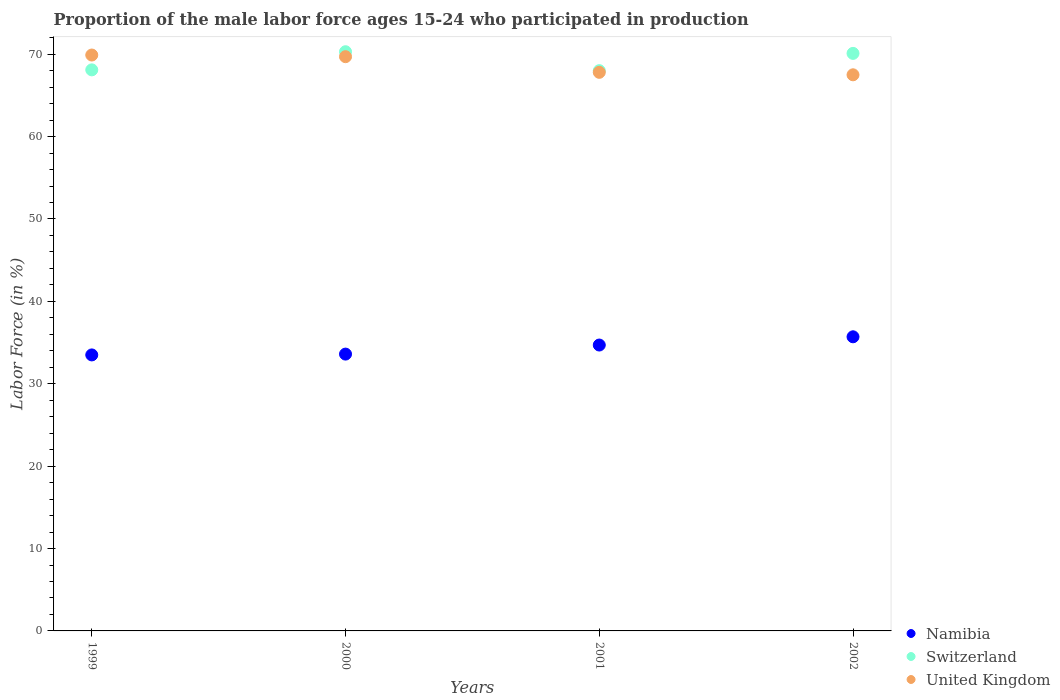How many different coloured dotlines are there?
Provide a short and direct response. 3. Is the number of dotlines equal to the number of legend labels?
Your answer should be compact. Yes. What is the proportion of the male labor force who participated in production in United Kingdom in 2000?
Offer a terse response. 69.7. Across all years, what is the maximum proportion of the male labor force who participated in production in United Kingdom?
Keep it short and to the point. 69.9. Across all years, what is the minimum proportion of the male labor force who participated in production in United Kingdom?
Offer a very short reply. 67.5. In which year was the proportion of the male labor force who participated in production in United Kingdom minimum?
Your answer should be compact. 2002. What is the total proportion of the male labor force who participated in production in Namibia in the graph?
Offer a very short reply. 137.5. What is the difference between the proportion of the male labor force who participated in production in Switzerland in 1999 and that in 2000?
Provide a short and direct response. -2.2. What is the difference between the proportion of the male labor force who participated in production in Switzerland in 2002 and the proportion of the male labor force who participated in production in Namibia in 2000?
Provide a succinct answer. 36.5. What is the average proportion of the male labor force who participated in production in Switzerland per year?
Offer a terse response. 69.12. In the year 2001, what is the difference between the proportion of the male labor force who participated in production in United Kingdom and proportion of the male labor force who participated in production in Namibia?
Your answer should be compact. 33.1. What is the ratio of the proportion of the male labor force who participated in production in United Kingdom in 2000 to that in 2001?
Provide a short and direct response. 1.03. Is the proportion of the male labor force who participated in production in Namibia in 1999 less than that in 2001?
Keep it short and to the point. Yes. Is the difference between the proportion of the male labor force who participated in production in United Kingdom in 1999 and 2000 greater than the difference between the proportion of the male labor force who participated in production in Namibia in 1999 and 2000?
Offer a very short reply. Yes. What is the difference between the highest and the second highest proportion of the male labor force who participated in production in Switzerland?
Offer a terse response. 0.2. What is the difference between the highest and the lowest proportion of the male labor force who participated in production in United Kingdom?
Give a very brief answer. 2.4. In how many years, is the proportion of the male labor force who participated in production in Switzerland greater than the average proportion of the male labor force who participated in production in Switzerland taken over all years?
Keep it short and to the point. 2. Is it the case that in every year, the sum of the proportion of the male labor force who participated in production in United Kingdom and proportion of the male labor force who participated in production in Namibia  is greater than the proportion of the male labor force who participated in production in Switzerland?
Your answer should be very brief. Yes. Does the proportion of the male labor force who participated in production in Namibia monotonically increase over the years?
Keep it short and to the point. Yes. Is the proportion of the male labor force who participated in production in United Kingdom strictly greater than the proportion of the male labor force who participated in production in Namibia over the years?
Keep it short and to the point. Yes. How many dotlines are there?
Your answer should be compact. 3. How many years are there in the graph?
Your response must be concise. 4. Does the graph contain grids?
Make the answer very short. No. Where does the legend appear in the graph?
Make the answer very short. Bottom right. How many legend labels are there?
Your answer should be compact. 3. How are the legend labels stacked?
Provide a succinct answer. Vertical. What is the title of the graph?
Ensure brevity in your answer.  Proportion of the male labor force ages 15-24 who participated in production. What is the Labor Force (in %) in Namibia in 1999?
Give a very brief answer. 33.5. What is the Labor Force (in %) in Switzerland in 1999?
Give a very brief answer. 68.1. What is the Labor Force (in %) of United Kingdom in 1999?
Offer a terse response. 69.9. What is the Labor Force (in %) in Namibia in 2000?
Ensure brevity in your answer.  33.6. What is the Labor Force (in %) in Switzerland in 2000?
Make the answer very short. 70.3. What is the Labor Force (in %) of United Kingdom in 2000?
Provide a succinct answer. 69.7. What is the Labor Force (in %) of Namibia in 2001?
Make the answer very short. 34.7. What is the Labor Force (in %) in Switzerland in 2001?
Provide a succinct answer. 68. What is the Labor Force (in %) of United Kingdom in 2001?
Ensure brevity in your answer.  67.8. What is the Labor Force (in %) in Namibia in 2002?
Give a very brief answer. 35.7. What is the Labor Force (in %) of Switzerland in 2002?
Provide a succinct answer. 70.1. What is the Labor Force (in %) in United Kingdom in 2002?
Your answer should be compact. 67.5. Across all years, what is the maximum Labor Force (in %) in Namibia?
Provide a short and direct response. 35.7. Across all years, what is the maximum Labor Force (in %) of Switzerland?
Make the answer very short. 70.3. Across all years, what is the maximum Labor Force (in %) of United Kingdom?
Offer a very short reply. 69.9. Across all years, what is the minimum Labor Force (in %) in Namibia?
Keep it short and to the point. 33.5. Across all years, what is the minimum Labor Force (in %) of United Kingdom?
Ensure brevity in your answer.  67.5. What is the total Labor Force (in %) in Namibia in the graph?
Provide a short and direct response. 137.5. What is the total Labor Force (in %) of Switzerland in the graph?
Offer a very short reply. 276.5. What is the total Labor Force (in %) of United Kingdom in the graph?
Keep it short and to the point. 274.9. What is the difference between the Labor Force (in %) in Namibia in 1999 and that in 2001?
Offer a terse response. -1.2. What is the difference between the Labor Force (in %) in Switzerland in 1999 and that in 2001?
Keep it short and to the point. 0.1. What is the difference between the Labor Force (in %) of United Kingdom in 1999 and that in 2001?
Provide a short and direct response. 2.1. What is the difference between the Labor Force (in %) of Namibia in 1999 and that in 2002?
Your answer should be compact. -2.2. What is the difference between the Labor Force (in %) of United Kingdom in 1999 and that in 2002?
Offer a very short reply. 2.4. What is the difference between the Labor Force (in %) of Namibia in 2000 and that in 2001?
Give a very brief answer. -1.1. What is the difference between the Labor Force (in %) in Switzerland in 2000 and that in 2001?
Ensure brevity in your answer.  2.3. What is the difference between the Labor Force (in %) of United Kingdom in 2000 and that in 2001?
Your answer should be compact. 1.9. What is the difference between the Labor Force (in %) of Namibia in 2000 and that in 2002?
Offer a very short reply. -2.1. What is the difference between the Labor Force (in %) in United Kingdom in 2000 and that in 2002?
Your answer should be compact. 2.2. What is the difference between the Labor Force (in %) in United Kingdom in 2001 and that in 2002?
Offer a very short reply. 0.3. What is the difference between the Labor Force (in %) of Namibia in 1999 and the Labor Force (in %) of Switzerland in 2000?
Make the answer very short. -36.8. What is the difference between the Labor Force (in %) of Namibia in 1999 and the Labor Force (in %) of United Kingdom in 2000?
Give a very brief answer. -36.2. What is the difference between the Labor Force (in %) of Namibia in 1999 and the Labor Force (in %) of Switzerland in 2001?
Make the answer very short. -34.5. What is the difference between the Labor Force (in %) of Namibia in 1999 and the Labor Force (in %) of United Kingdom in 2001?
Provide a short and direct response. -34.3. What is the difference between the Labor Force (in %) in Switzerland in 1999 and the Labor Force (in %) in United Kingdom in 2001?
Your answer should be very brief. 0.3. What is the difference between the Labor Force (in %) in Namibia in 1999 and the Labor Force (in %) in Switzerland in 2002?
Your answer should be very brief. -36.6. What is the difference between the Labor Force (in %) in Namibia in 1999 and the Labor Force (in %) in United Kingdom in 2002?
Provide a succinct answer. -34. What is the difference between the Labor Force (in %) in Namibia in 2000 and the Labor Force (in %) in Switzerland in 2001?
Offer a terse response. -34.4. What is the difference between the Labor Force (in %) of Namibia in 2000 and the Labor Force (in %) of United Kingdom in 2001?
Give a very brief answer. -34.2. What is the difference between the Labor Force (in %) in Namibia in 2000 and the Labor Force (in %) in Switzerland in 2002?
Offer a very short reply. -36.5. What is the difference between the Labor Force (in %) in Namibia in 2000 and the Labor Force (in %) in United Kingdom in 2002?
Offer a very short reply. -33.9. What is the difference between the Labor Force (in %) of Namibia in 2001 and the Labor Force (in %) of Switzerland in 2002?
Keep it short and to the point. -35.4. What is the difference between the Labor Force (in %) of Namibia in 2001 and the Labor Force (in %) of United Kingdom in 2002?
Give a very brief answer. -32.8. What is the difference between the Labor Force (in %) in Switzerland in 2001 and the Labor Force (in %) in United Kingdom in 2002?
Provide a succinct answer. 0.5. What is the average Labor Force (in %) of Namibia per year?
Provide a short and direct response. 34.38. What is the average Labor Force (in %) in Switzerland per year?
Offer a terse response. 69.12. What is the average Labor Force (in %) of United Kingdom per year?
Provide a succinct answer. 68.72. In the year 1999, what is the difference between the Labor Force (in %) in Namibia and Labor Force (in %) in Switzerland?
Your answer should be very brief. -34.6. In the year 1999, what is the difference between the Labor Force (in %) in Namibia and Labor Force (in %) in United Kingdom?
Keep it short and to the point. -36.4. In the year 1999, what is the difference between the Labor Force (in %) in Switzerland and Labor Force (in %) in United Kingdom?
Keep it short and to the point. -1.8. In the year 2000, what is the difference between the Labor Force (in %) in Namibia and Labor Force (in %) in Switzerland?
Keep it short and to the point. -36.7. In the year 2000, what is the difference between the Labor Force (in %) of Namibia and Labor Force (in %) of United Kingdom?
Your answer should be compact. -36.1. In the year 2000, what is the difference between the Labor Force (in %) of Switzerland and Labor Force (in %) of United Kingdom?
Your answer should be compact. 0.6. In the year 2001, what is the difference between the Labor Force (in %) in Namibia and Labor Force (in %) in Switzerland?
Keep it short and to the point. -33.3. In the year 2001, what is the difference between the Labor Force (in %) of Namibia and Labor Force (in %) of United Kingdom?
Make the answer very short. -33.1. In the year 2002, what is the difference between the Labor Force (in %) of Namibia and Labor Force (in %) of Switzerland?
Offer a terse response. -34.4. In the year 2002, what is the difference between the Labor Force (in %) of Namibia and Labor Force (in %) of United Kingdom?
Keep it short and to the point. -31.8. What is the ratio of the Labor Force (in %) of Namibia in 1999 to that in 2000?
Offer a very short reply. 1. What is the ratio of the Labor Force (in %) of Switzerland in 1999 to that in 2000?
Keep it short and to the point. 0.97. What is the ratio of the Labor Force (in %) in Namibia in 1999 to that in 2001?
Provide a succinct answer. 0.97. What is the ratio of the Labor Force (in %) of United Kingdom in 1999 to that in 2001?
Offer a terse response. 1.03. What is the ratio of the Labor Force (in %) in Namibia in 1999 to that in 2002?
Give a very brief answer. 0.94. What is the ratio of the Labor Force (in %) in Switzerland in 1999 to that in 2002?
Offer a very short reply. 0.97. What is the ratio of the Labor Force (in %) of United Kingdom in 1999 to that in 2002?
Offer a terse response. 1.04. What is the ratio of the Labor Force (in %) in Namibia in 2000 to that in 2001?
Your response must be concise. 0.97. What is the ratio of the Labor Force (in %) of Switzerland in 2000 to that in 2001?
Offer a terse response. 1.03. What is the ratio of the Labor Force (in %) in United Kingdom in 2000 to that in 2001?
Keep it short and to the point. 1.03. What is the ratio of the Labor Force (in %) in Namibia in 2000 to that in 2002?
Offer a very short reply. 0.94. What is the ratio of the Labor Force (in %) in United Kingdom in 2000 to that in 2002?
Offer a very short reply. 1.03. What is the difference between the highest and the second highest Labor Force (in %) in Switzerland?
Provide a succinct answer. 0.2. What is the difference between the highest and the lowest Labor Force (in %) of Switzerland?
Your answer should be very brief. 2.3. 